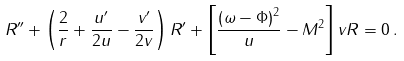Convert formula to latex. <formula><loc_0><loc_0><loc_500><loc_500>R ^ { \prime \prime } + \left ( \frac { 2 } { r } + \frac { u ^ { \prime } } { 2 u } - \frac { v ^ { \prime } } { 2 v } \right ) R ^ { \prime } + \left [ \frac { \left ( \omega - \Phi \right ) ^ { 2 } } { u } - M ^ { 2 } \right ] v R = 0 \, .</formula> 